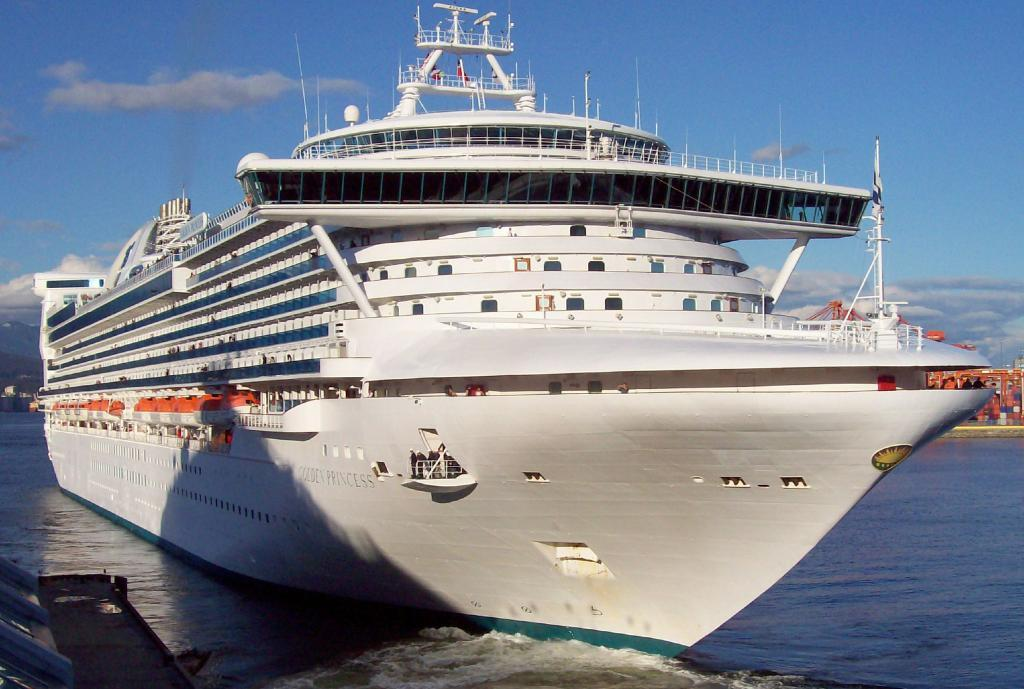What is the main subject in the center of the image? There is a ship in the center of the image. What is the color of the ship? The ship is white in color. What can be seen on the right side of the image? There is an object on the water on the right side of the image. How would you describe the sky in the image? The sky is cloudy. What type of meat is hanging from the wire in the image? There is no wire or meat present in the image; it features a ship and an object on the water. How many chickens are visible in the image? There are no chickens visible in the image. 